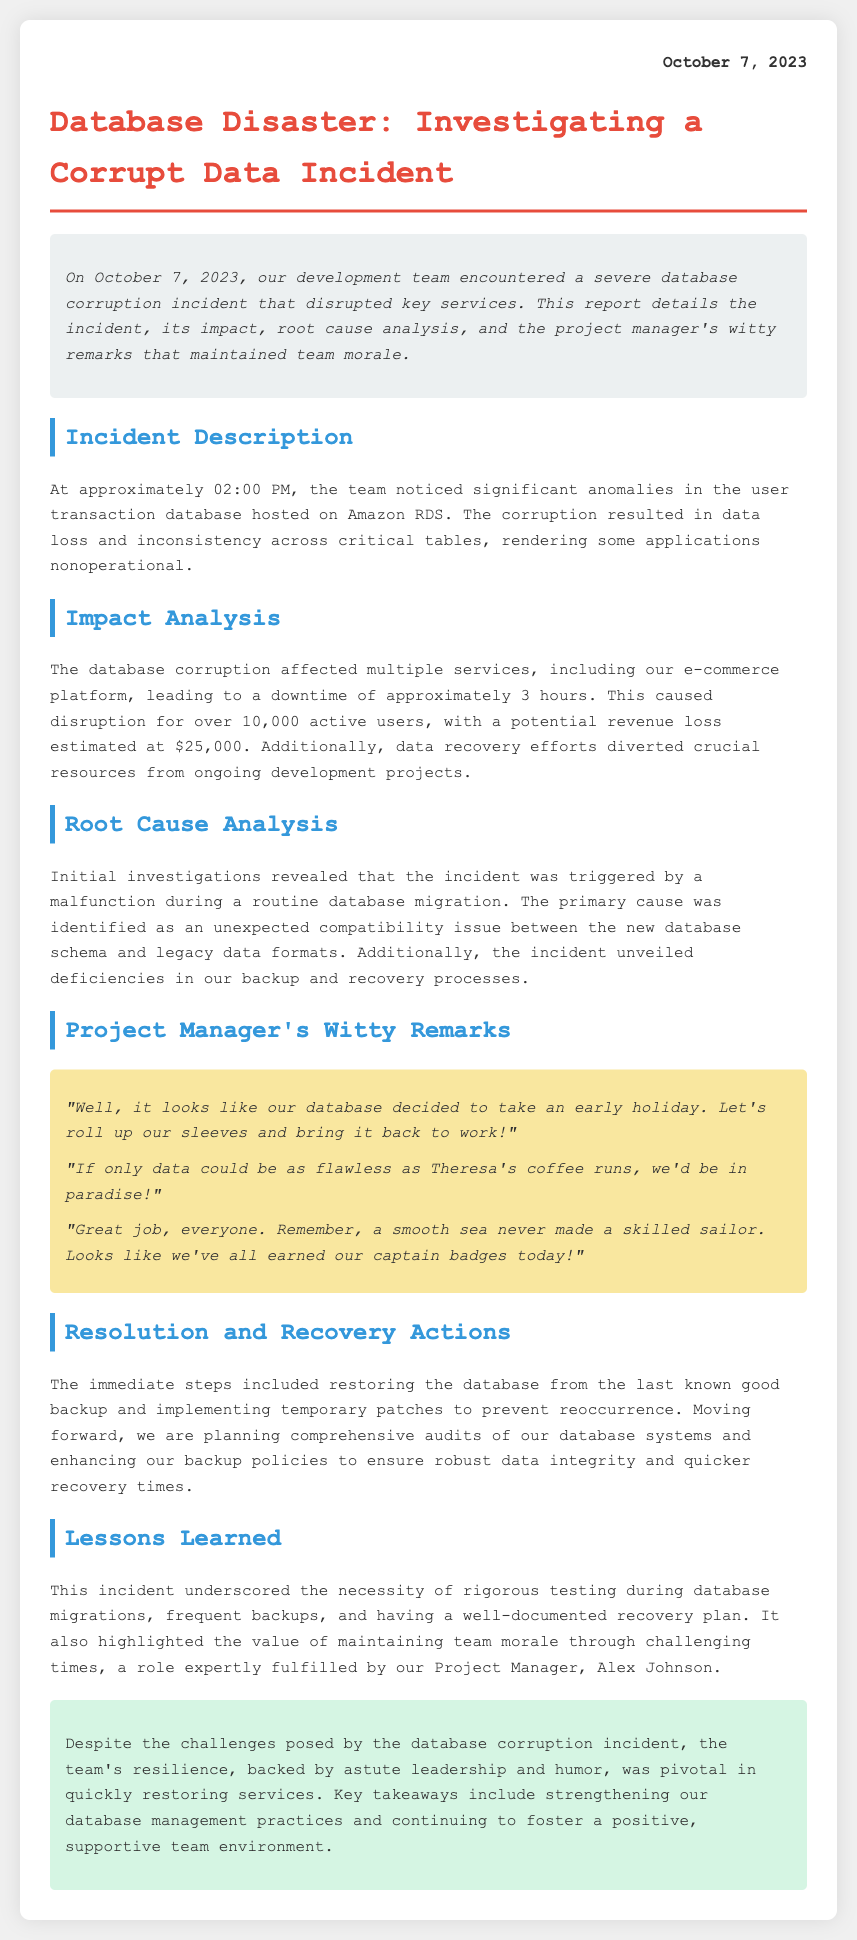what date was the incident reported? The incident is dated October 7, 2023, as stated at the top of the report.
Answer: October 7, 2023 how long was the downtime caused by the incident? The downtime is explicitly mentioned as approximately 3 hours due to the database corruption incident.
Answer: 3 hours what was the potential revenue loss estimated at? The report provides the potential revenue loss as a monetary figure of $25,000.
Answer: $25,000 who maintained team morale during the incident? The report identifies the individual responsible for maintaining team morale as Project Manager Alex Johnson.
Answer: Alex Johnson what caused the database corruption incident? The incident was triggered by a malfunction during a routine database migration, which is highlighted in the root cause analysis section.
Answer: a malfunction during a routine database migration how many active users were affected by the incident? The report notes that over 10,000 active users were affected by the disruption caused by the incident.
Answer: over 10,000 what lesson was learned from this incident regarding database migrations? The document highlights the necessity of rigorous testing during database migrations as a key lesson learned from the incident.
Answer: rigorous testing which metaphor did the Project Manager use to encourage the team? The Project Manager used the metaphor of a "smooth sea never made a skilled sailor" to encourage the team, indicating the value of challenges.
Answer: a smooth sea never made a skilled sailor 